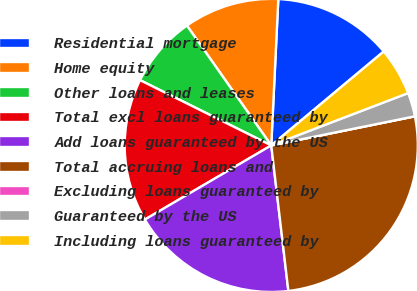Convert chart. <chart><loc_0><loc_0><loc_500><loc_500><pie_chart><fcel>Residential mortgage<fcel>Home equity<fcel>Other loans and leases<fcel>Total excl loans guaranteed by<fcel>Add loans guaranteed by the US<fcel>Total accruing loans and<fcel>Excluding loans guaranteed by<fcel>Guaranteed by the US<fcel>Including loans guaranteed by<nl><fcel>13.16%<fcel>10.53%<fcel>7.89%<fcel>15.79%<fcel>18.42%<fcel>26.32%<fcel>0.0%<fcel>2.63%<fcel>5.26%<nl></chart> 